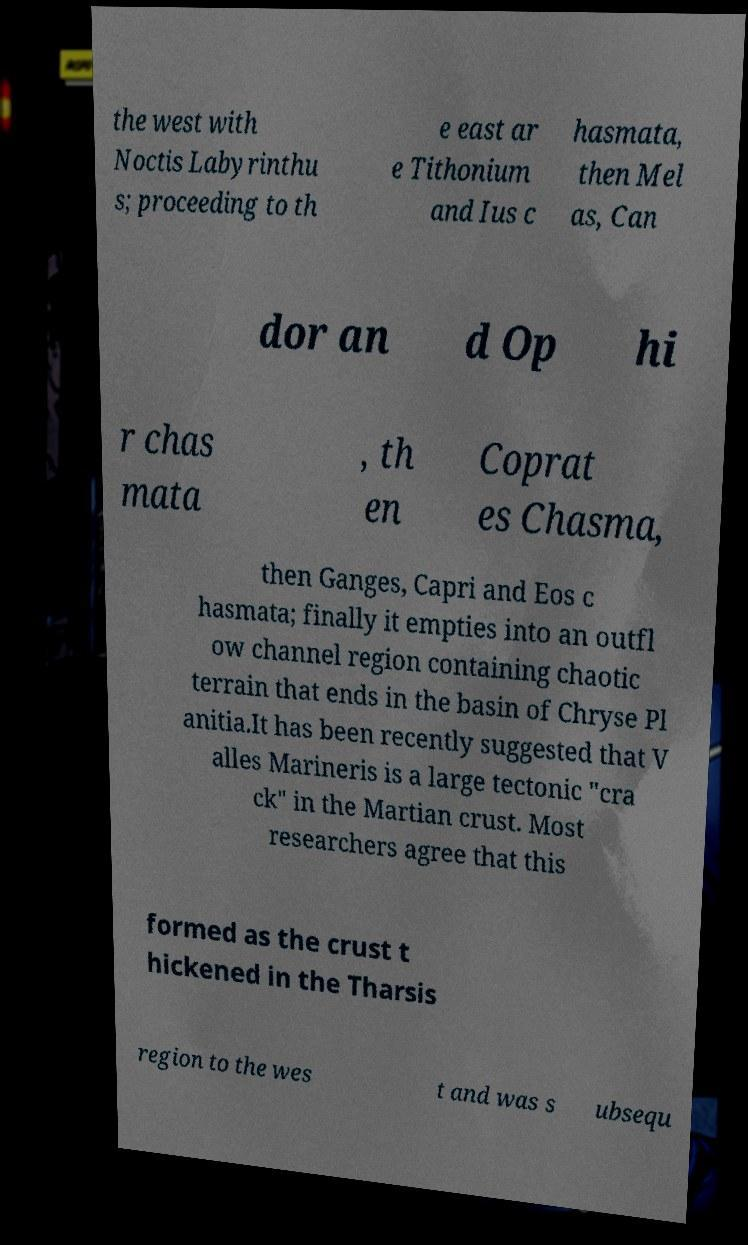Can you read and provide the text displayed in the image?This photo seems to have some interesting text. Can you extract and type it out for me? the west with Noctis Labyrinthu s; proceeding to th e east ar e Tithonium and Ius c hasmata, then Mel as, Can dor an d Op hi r chas mata , th en Coprat es Chasma, then Ganges, Capri and Eos c hasmata; finally it empties into an outfl ow channel region containing chaotic terrain that ends in the basin of Chryse Pl anitia.It has been recently suggested that V alles Marineris is a large tectonic "cra ck" in the Martian crust. Most researchers agree that this formed as the crust t hickened in the Tharsis region to the wes t and was s ubsequ 